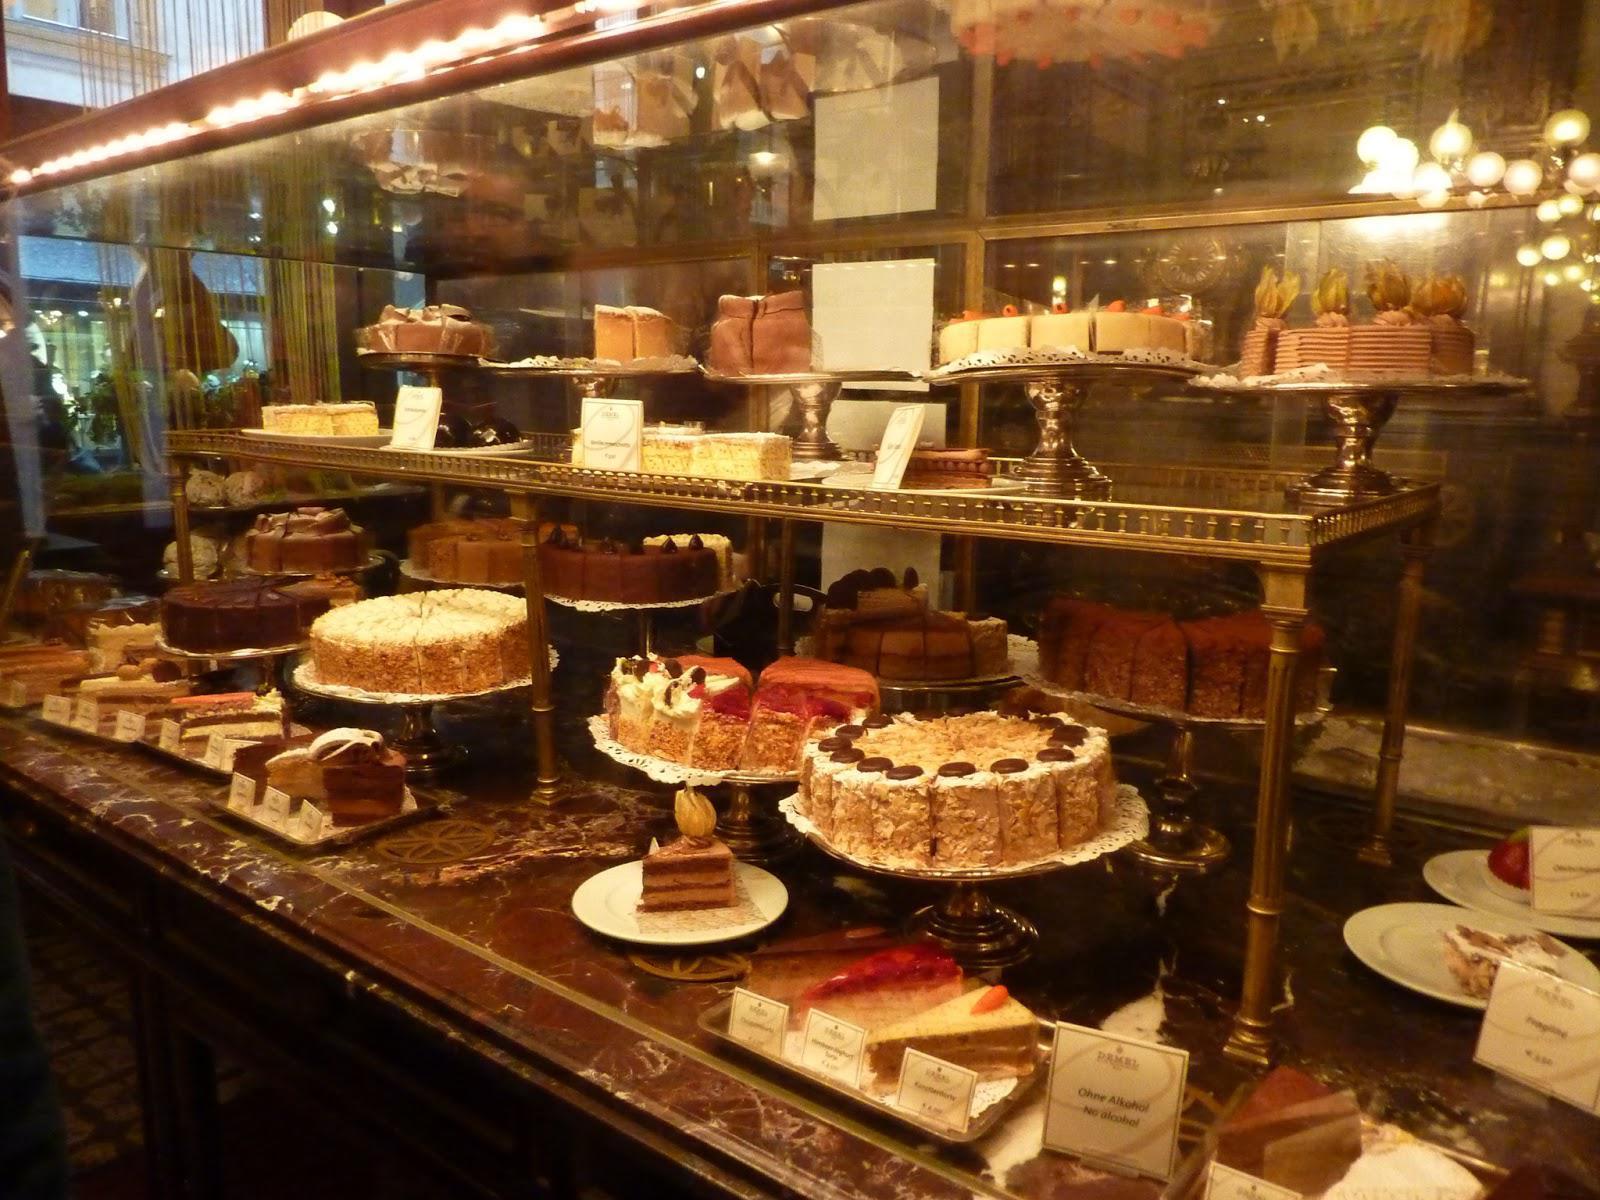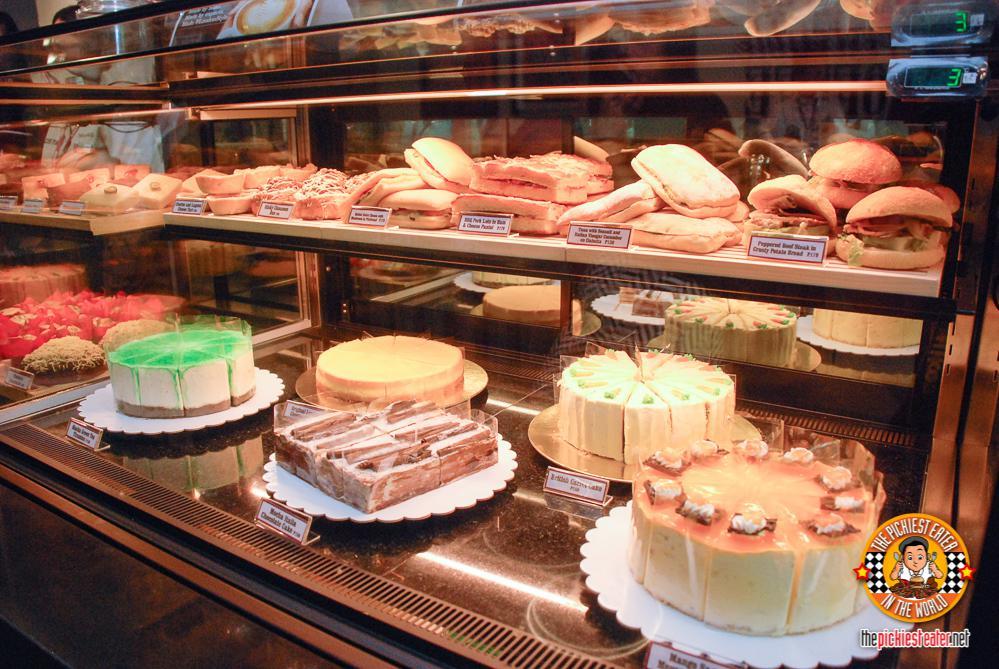The first image is the image on the left, the second image is the image on the right. Analyze the images presented: Is the assertion "An image features cakes on pedestal stands under a top tier supported by ornate columns with more cakes on pedestals." valid? Answer yes or no. Yes. The first image is the image on the left, the second image is the image on the right. Evaluate the accuracy of this statement regarding the images: "In the image to the right, at least one cake has strawberry on it.". Is it true? Answer yes or no. No. 